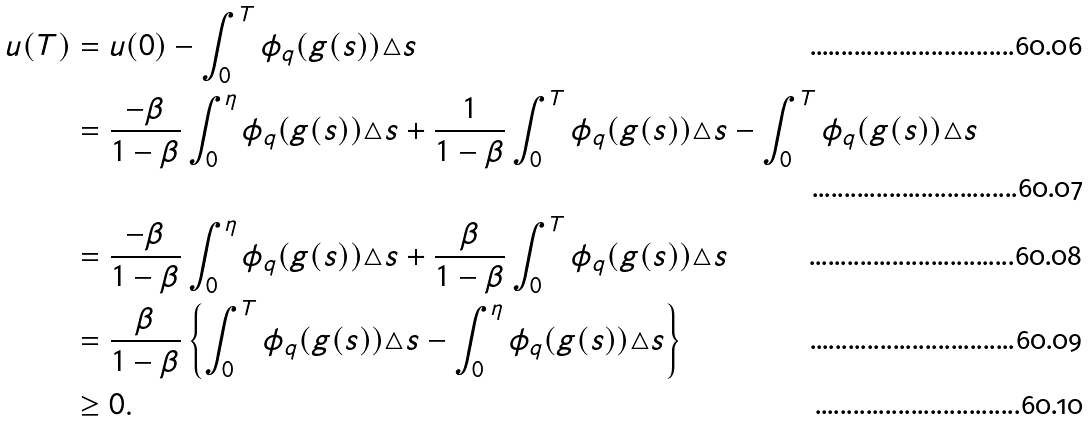Convert formula to latex. <formula><loc_0><loc_0><loc_500><loc_500>u ( T ) & = u ( 0 ) - \int _ { 0 } ^ { T } \phi _ { q } ( g ( s ) ) \triangle s \\ & = \frac { - \beta } { 1 - \beta } \int _ { 0 } ^ { \eta } \phi _ { q } ( g ( s ) ) \triangle s + \frac { 1 } { 1 - \beta } \int _ { 0 } ^ { T } \phi _ { q } ( g ( s ) ) \triangle s - \int _ { 0 } ^ { T } \phi _ { q } ( g ( s ) ) \triangle s \\ & = \frac { - \beta } { 1 - \beta } \int _ { 0 } ^ { \eta } \phi _ { q } ( g ( s ) ) \triangle s + \frac { \beta } { 1 - \beta } \int _ { 0 } ^ { T } \phi _ { q } ( g ( s ) ) \triangle s \\ & = \frac { \beta } { 1 - \beta } \left \{ \int _ { 0 } ^ { T } \phi _ { q } ( g ( s ) ) \triangle s - \int _ { 0 } ^ { \eta } \phi _ { q } ( g ( s ) ) \triangle s \right \} \\ & \geq 0 .</formula> 